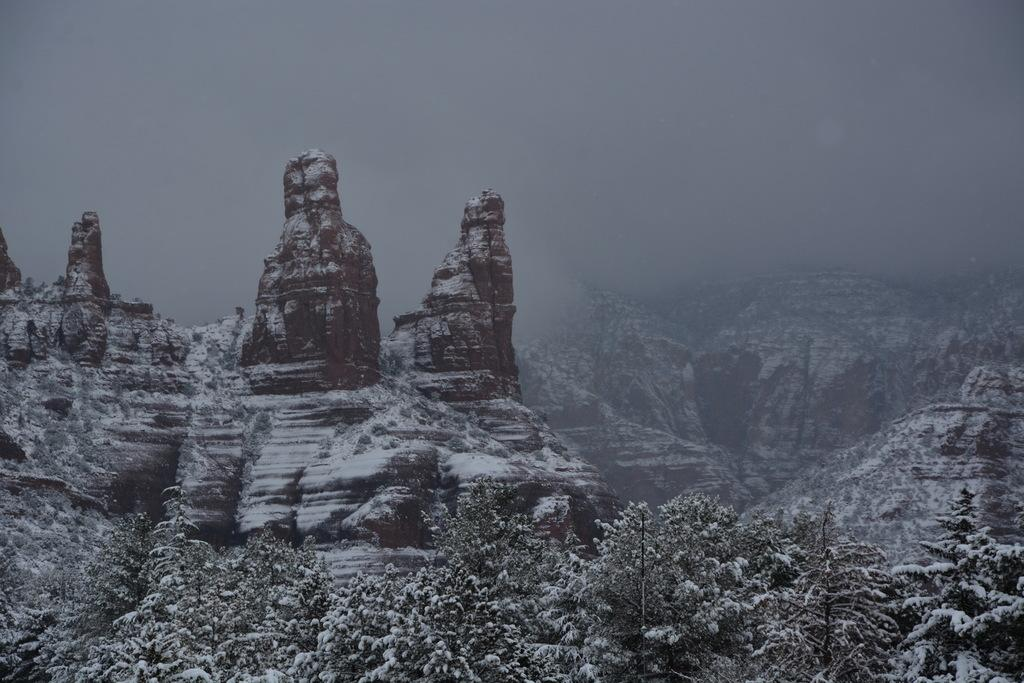What type of vegetation is present in the image? There are trees in the image. What is covering the trees in the image? The trees are covered with snow. What other objects can be seen in the image? There are rocks in the image. What is covering the rocks in the image? The rocks are covered with snow. What type of mark can be seen on the trees in the image? There is no specific mark mentioned in the facts, and the image does not show any marks on the trees. 